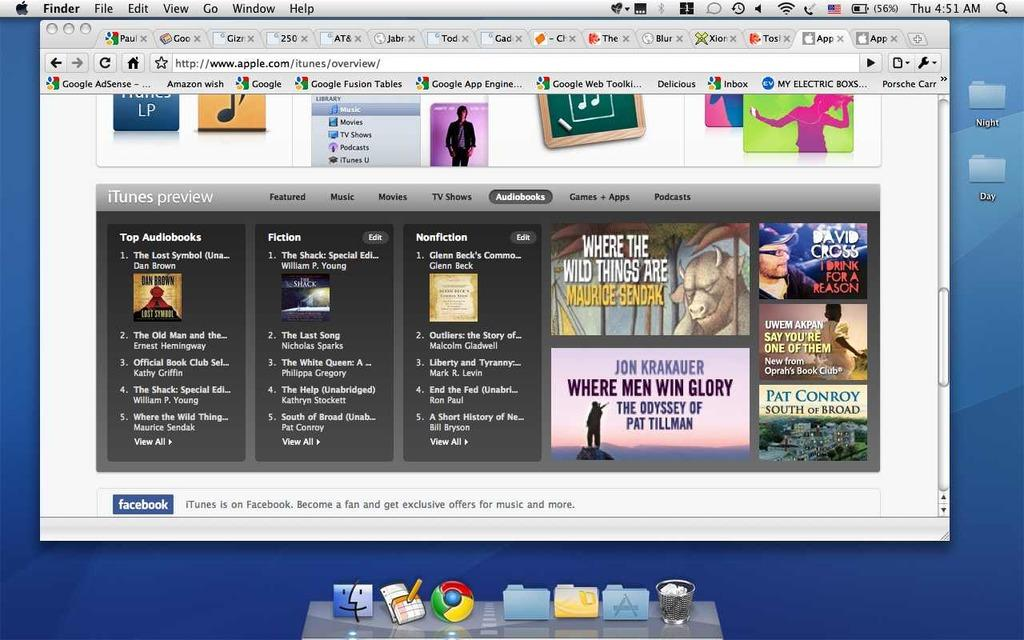<image>
Provide a brief description of the given image. An internet browser is opened to the apple website.. 